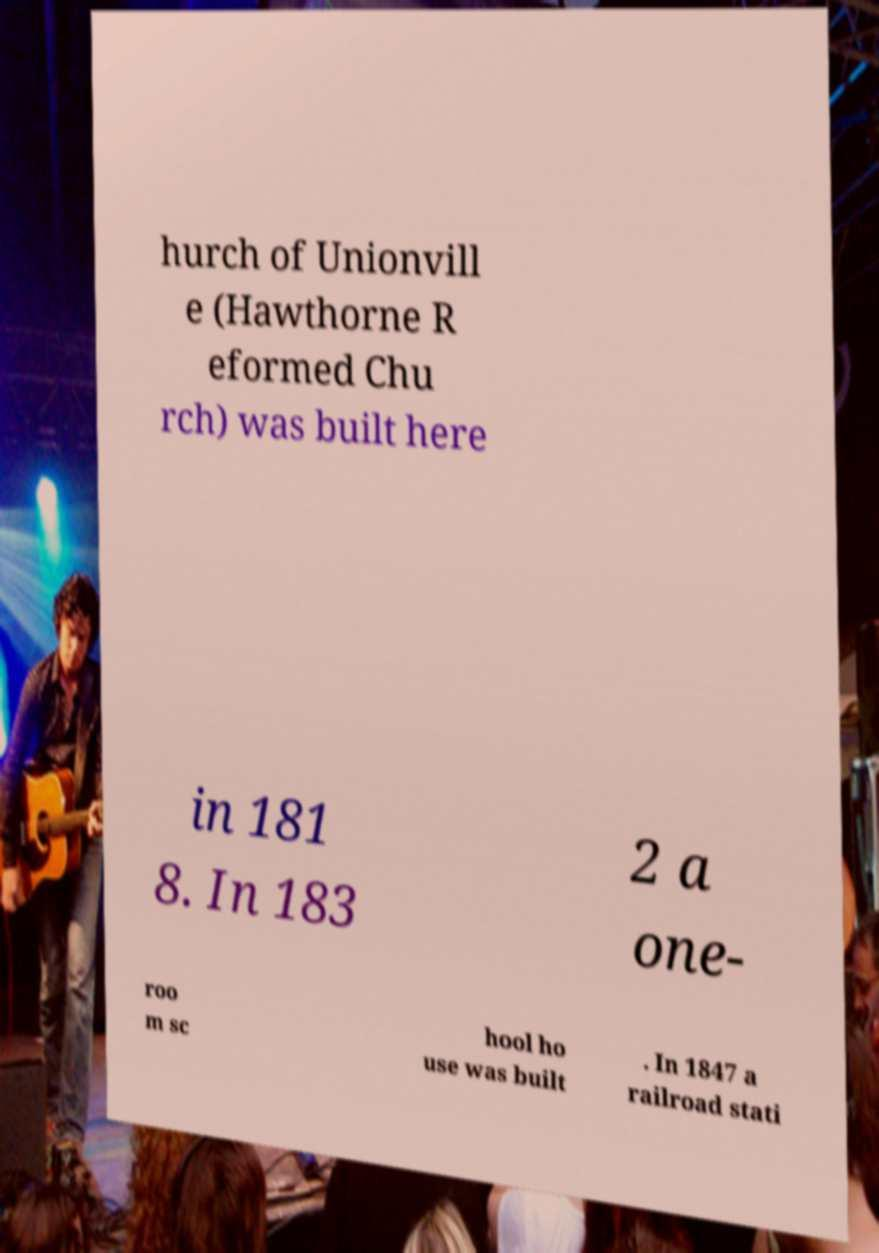Could you assist in decoding the text presented in this image and type it out clearly? hurch of Unionvill e (Hawthorne R eformed Chu rch) was built here in 181 8. In 183 2 a one- roo m sc hool ho use was built . In 1847 a railroad stati 